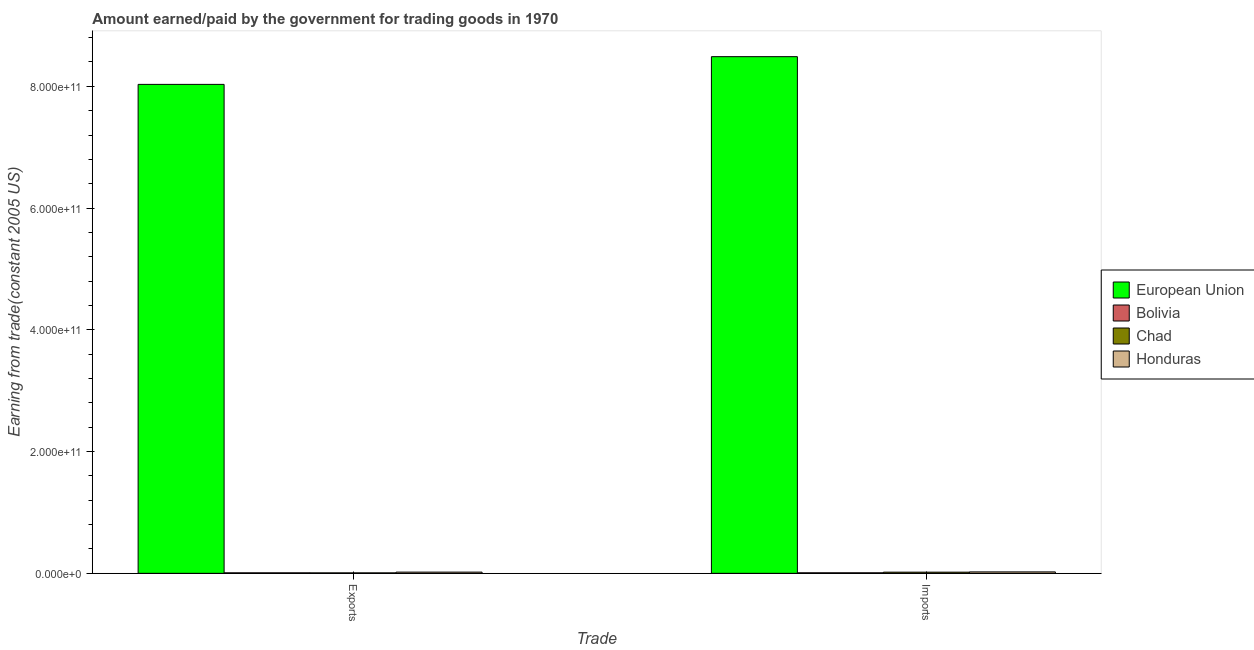How many different coloured bars are there?
Make the answer very short. 4. How many groups of bars are there?
Provide a short and direct response. 2. Are the number of bars per tick equal to the number of legend labels?
Your answer should be very brief. Yes. How many bars are there on the 2nd tick from the right?
Your response must be concise. 4. What is the label of the 2nd group of bars from the left?
Your response must be concise. Imports. What is the amount earned from exports in European Union?
Keep it short and to the point. 8.03e+11. Across all countries, what is the maximum amount paid for imports?
Your answer should be compact. 8.49e+11. Across all countries, what is the minimum amount earned from exports?
Make the answer very short. 7.57e+08. In which country was the amount paid for imports maximum?
Give a very brief answer. European Union. In which country was the amount earned from exports minimum?
Ensure brevity in your answer.  Chad. What is the total amount earned from exports in the graph?
Keep it short and to the point. 8.07e+11. What is the difference between the amount earned from exports in Honduras and that in European Union?
Give a very brief answer. -8.01e+11. What is the difference between the amount paid for imports in European Union and the amount earned from exports in Honduras?
Offer a terse response. 8.47e+11. What is the average amount earned from exports per country?
Offer a terse response. 2.02e+11. What is the difference between the amount paid for imports and amount earned from exports in Chad?
Offer a very short reply. 1.15e+09. What is the ratio of the amount earned from exports in Honduras to that in Bolivia?
Your answer should be compact. 2.39. What does the 1st bar from the right in Imports represents?
Your answer should be compact. Honduras. How many bars are there?
Your answer should be compact. 8. What is the difference between two consecutive major ticks on the Y-axis?
Provide a short and direct response. 2.00e+11. Are the values on the major ticks of Y-axis written in scientific E-notation?
Your answer should be compact. Yes. Does the graph contain any zero values?
Your answer should be compact. No. Does the graph contain grids?
Your answer should be compact. No. Where does the legend appear in the graph?
Make the answer very short. Center right. How many legend labels are there?
Keep it short and to the point. 4. What is the title of the graph?
Give a very brief answer. Amount earned/paid by the government for trading goods in 1970. Does "OECD members" appear as one of the legend labels in the graph?
Your answer should be very brief. No. What is the label or title of the X-axis?
Ensure brevity in your answer.  Trade. What is the label or title of the Y-axis?
Provide a short and direct response. Earning from trade(constant 2005 US). What is the Earning from trade(constant 2005 US) of European Union in Exports?
Give a very brief answer. 8.03e+11. What is the Earning from trade(constant 2005 US) of Bolivia in Exports?
Your answer should be very brief. 8.33e+08. What is the Earning from trade(constant 2005 US) in Chad in Exports?
Offer a very short reply. 7.57e+08. What is the Earning from trade(constant 2005 US) in Honduras in Exports?
Your answer should be compact. 1.99e+09. What is the Earning from trade(constant 2005 US) of European Union in Imports?
Your answer should be compact. 8.49e+11. What is the Earning from trade(constant 2005 US) in Bolivia in Imports?
Keep it short and to the point. 8.89e+08. What is the Earning from trade(constant 2005 US) in Chad in Imports?
Provide a succinct answer. 1.91e+09. What is the Earning from trade(constant 2005 US) in Honduras in Imports?
Make the answer very short. 2.35e+09. Across all Trade, what is the maximum Earning from trade(constant 2005 US) in European Union?
Make the answer very short. 8.49e+11. Across all Trade, what is the maximum Earning from trade(constant 2005 US) of Bolivia?
Make the answer very short. 8.89e+08. Across all Trade, what is the maximum Earning from trade(constant 2005 US) in Chad?
Provide a short and direct response. 1.91e+09. Across all Trade, what is the maximum Earning from trade(constant 2005 US) in Honduras?
Your answer should be compact. 2.35e+09. Across all Trade, what is the minimum Earning from trade(constant 2005 US) in European Union?
Your answer should be very brief. 8.03e+11. Across all Trade, what is the minimum Earning from trade(constant 2005 US) of Bolivia?
Your answer should be compact. 8.33e+08. Across all Trade, what is the minimum Earning from trade(constant 2005 US) in Chad?
Give a very brief answer. 7.57e+08. Across all Trade, what is the minimum Earning from trade(constant 2005 US) of Honduras?
Give a very brief answer. 1.99e+09. What is the total Earning from trade(constant 2005 US) of European Union in the graph?
Keep it short and to the point. 1.65e+12. What is the total Earning from trade(constant 2005 US) of Bolivia in the graph?
Ensure brevity in your answer.  1.72e+09. What is the total Earning from trade(constant 2005 US) of Chad in the graph?
Offer a very short reply. 2.67e+09. What is the total Earning from trade(constant 2005 US) in Honduras in the graph?
Offer a very short reply. 4.34e+09. What is the difference between the Earning from trade(constant 2005 US) in European Union in Exports and that in Imports?
Keep it short and to the point. -4.55e+1. What is the difference between the Earning from trade(constant 2005 US) of Bolivia in Exports and that in Imports?
Give a very brief answer. -5.57e+07. What is the difference between the Earning from trade(constant 2005 US) in Chad in Exports and that in Imports?
Offer a terse response. -1.15e+09. What is the difference between the Earning from trade(constant 2005 US) in Honduras in Exports and that in Imports?
Make the answer very short. -3.53e+08. What is the difference between the Earning from trade(constant 2005 US) of European Union in Exports and the Earning from trade(constant 2005 US) of Bolivia in Imports?
Ensure brevity in your answer.  8.02e+11. What is the difference between the Earning from trade(constant 2005 US) of European Union in Exports and the Earning from trade(constant 2005 US) of Chad in Imports?
Provide a succinct answer. 8.01e+11. What is the difference between the Earning from trade(constant 2005 US) of European Union in Exports and the Earning from trade(constant 2005 US) of Honduras in Imports?
Keep it short and to the point. 8.01e+11. What is the difference between the Earning from trade(constant 2005 US) of Bolivia in Exports and the Earning from trade(constant 2005 US) of Chad in Imports?
Your response must be concise. -1.08e+09. What is the difference between the Earning from trade(constant 2005 US) of Bolivia in Exports and the Earning from trade(constant 2005 US) of Honduras in Imports?
Keep it short and to the point. -1.51e+09. What is the difference between the Earning from trade(constant 2005 US) in Chad in Exports and the Earning from trade(constant 2005 US) in Honduras in Imports?
Your answer should be very brief. -1.59e+09. What is the average Earning from trade(constant 2005 US) of European Union per Trade?
Make the answer very short. 8.26e+11. What is the average Earning from trade(constant 2005 US) of Bolivia per Trade?
Offer a terse response. 8.61e+08. What is the average Earning from trade(constant 2005 US) of Chad per Trade?
Your response must be concise. 1.33e+09. What is the average Earning from trade(constant 2005 US) of Honduras per Trade?
Keep it short and to the point. 2.17e+09. What is the difference between the Earning from trade(constant 2005 US) of European Union and Earning from trade(constant 2005 US) of Bolivia in Exports?
Offer a terse response. 8.02e+11. What is the difference between the Earning from trade(constant 2005 US) of European Union and Earning from trade(constant 2005 US) of Chad in Exports?
Make the answer very short. 8.02e+11. What is the difference between the Earning from trade(constant 2005 US) of European Union and Earning from trade(constant 2005 US) of Honduras in Exports?
Offer a very short reply. 8.01e+11. What is the difference between the Earning from trade(constant 2005 US) in Bolivia and Earning from trade(constant 2005 US) in Chad in Exports?
Your answer should be very brief. 7.68e+07. What is the difference between the Earning from trade(constant 2005 US) of Bolivia and Earning from trade(constant 2005 US) of Honduras in Exports?
Make the answer very short. -1.16e+09. What is the difference between the Earning from trade(constant 2005 US) of Chad and Earning from trade(constant 2005 US) of Honduras in Exports?
Give a very brief answer. -1.24e+09. What is the difference between the Earning from trade(constant 2005 US) of European Union and Earning from trade(constant 2005 US) of Bolivia in Imports?
Give a very brief answer. 8.48e+11. What is the difference between the Earning from trade(constant 2005 US) in European Union and Earning from trade(constant 2005 US) in Chad in Imports?
Ensure brevity in your answer.  8.47e+11. What is the difference between the Earning from trade(constant 2005 US) of European Union and Earning from trade(constant 2005 US) of Honduras in Imports?
Offer a terse response. 8.46e+11. What is the difference between the Earning from trade(constant 2005 US) of Bolivia and Earning from trade(constant 2005 US) of Chad in Imports?
Ensure brevity in your answer.  -1.02e+09. What is the difference between the Earning from trade(constant 2005 US) in Bolivia and Earning from trade(constant 2005 US) in Honduras in Imports?
Your answer should be compact. -1.46e+09. What is the difference between the Earning from trade(constant 2005 US) in Chad and Earning from trade(constant 2005 US) in Honduras in Imports?
Give a very brief answer. -4.38e+08. What is the ratio of the Earning from trade(constant 2005 US) of European Union in Exports to that in Imports?
Keep it short and to the point. 0.95. What is the ratio of the Earning from trade(constant 2005 US) of Bolivia in Exports to that in Imports?
Offer a very short reply. 0.94. What is the ratio of the Earning from trade(constant 2005 US) of Chad in Exports to that in Imports?
Provide a succinct answer. 0.4. What is the ratio of the Earning from trade(constant 2005 US) in Honduras in Exports to that in Imports?
Your response must be concise. 0.85. What is the difference between the highest and the second highest Earning from trade(constant 2005 US) of European Union?
Provide a succinct answer. 4.55e+1. What is the difference between the highest and the second highest Earning from trade(constant 2005 US) of Bolivia?
Make the answer very short. 5.57e+07. What is the difference between the highest and the second highest Earning from trade(constant 2005 US) of Chad?
Your response must be concise. 1.15e+09. What is the difference between the highest and the second highest Earning from trade(constant 2005 US) in Honduras?
Your response must be concise. 3.53e+08. What is the difference between the highest and the lowest Earning from trade(constant 2005 US) of European Union?
Make the answer very short. 4.55e+1. What is the difference between the highest and the lowest Earning from trade(constant 2005 US) in Bolivia?
Keep it short and to the point. 5.57e+07. What is the difference between the highest and the lowest Earning from trade(constant 2005 US) of Chad?
Keep it short and to the point. 1.15e+09. What is the difference between the highest and the lowest Earning from trade(constant 2005 US) of Honduras?
Your answer should be compact. 3.53e+08. 